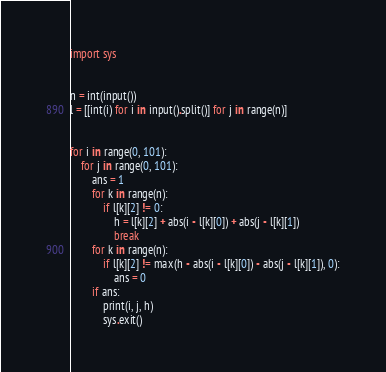<code> <loc_0><loc_0><loc_500><loc_500><_Python_>import sys


n = int(input())
l = [[int(i) for i in input().split()] for j in range(n)]


for i in range(0, 101):
    for j in range(0, 101):
        ans = 1
        for k in range(n):
            if l[k][2] != 0:
                h = l[k][2] + abs(i - l[k][0]) + abs(j - l[k][1])
                break
        for k in range(n):
            if l[k][2] != max(h - abs(i - l[k][0]) - abs(j - l[k][1]), 0):
                ans = 0
        if ans:
            print(i, j, h)
            sys.exit()
</code> 